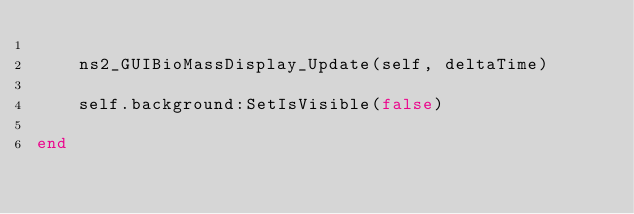<code> <loc_0><loc_0><loc_500><loc_500><_Lua_>
    ns2_GUIBioMassDisplay_Update(self, deltaTime)

    self.background:SetIsVisible(false)

end</code> 